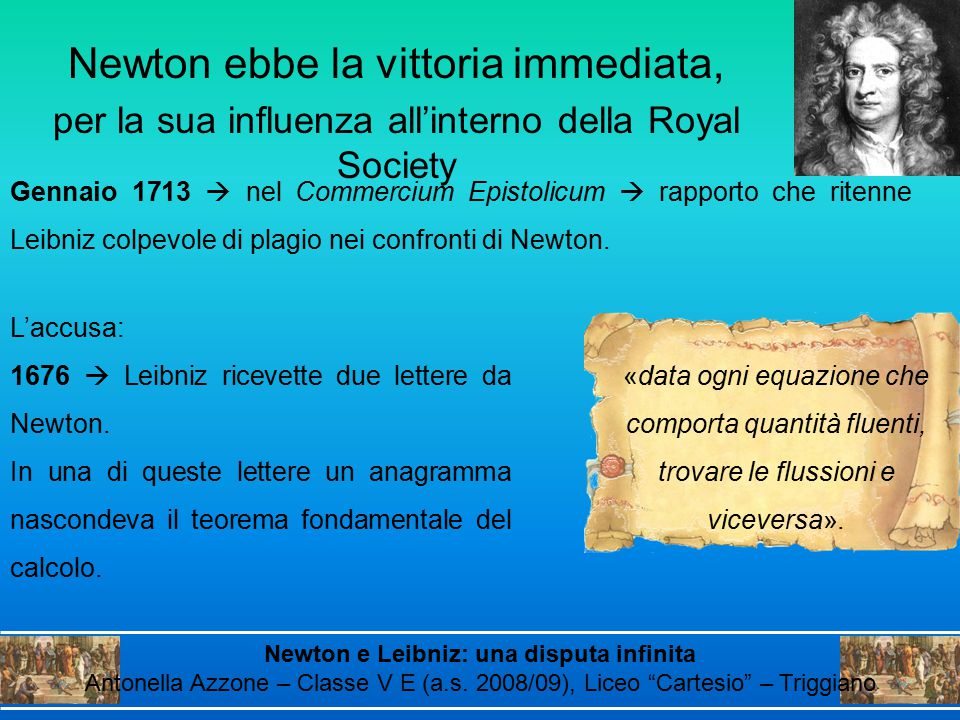If a movie were to be made about this historical dispute, what would be a dramatic scene involving the anagram? In a cinematic portrayal of the Newton-Leibniz dispute, a dramatic scene involving the anagram would be set in a dimly lit 17th-century study. The camera pans over cluttered desks, filled with manuscripts and quills. Newton, hunched over a desk, feverishly writes a letter by candlelight. As he encodes the anagram, the soundtrack crescendos, heightening the tension. The scene shifts to Leibniz, receiving and scrutinizing the letter by a roaring fireplace. A close-up reveals his furrowed brow as he deciphers the concealed message. The confrontation escalates in a grand hall of the Royal Society, where both men present their claims before an assembly of captivated scientists. Accusations of plagiarism fly, and the tension is palpable as the anagram's true meaning is unveiled, dramatically altering the audience's perceptions of both mathematicians. 